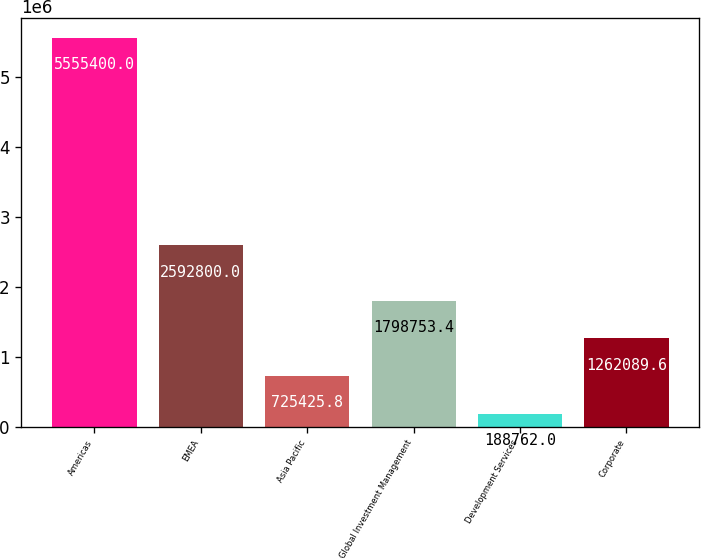Convert chart. <chart><loc_0><loc_0><loc_500><loc_500><bar_chart><fcel>Americas<fcel>EMEA<fcel>Asia Pacific<fcel>Global Investment Management<fcel>Development Services<fcel>Corporate<nl><fcel>5.5554e+06<fcel>2.5928e+06<fcel>725426<fcel>1.79875e+06<fcel>188762<fcel>1.26209e+06<nl></chart> 